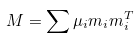Convert formula to latex. <formula><loc_0><loc_0><loc_500><loc_500>M = \sum \mu _ { i } m _ { i } m _ { i } ^ { T }</formula> 